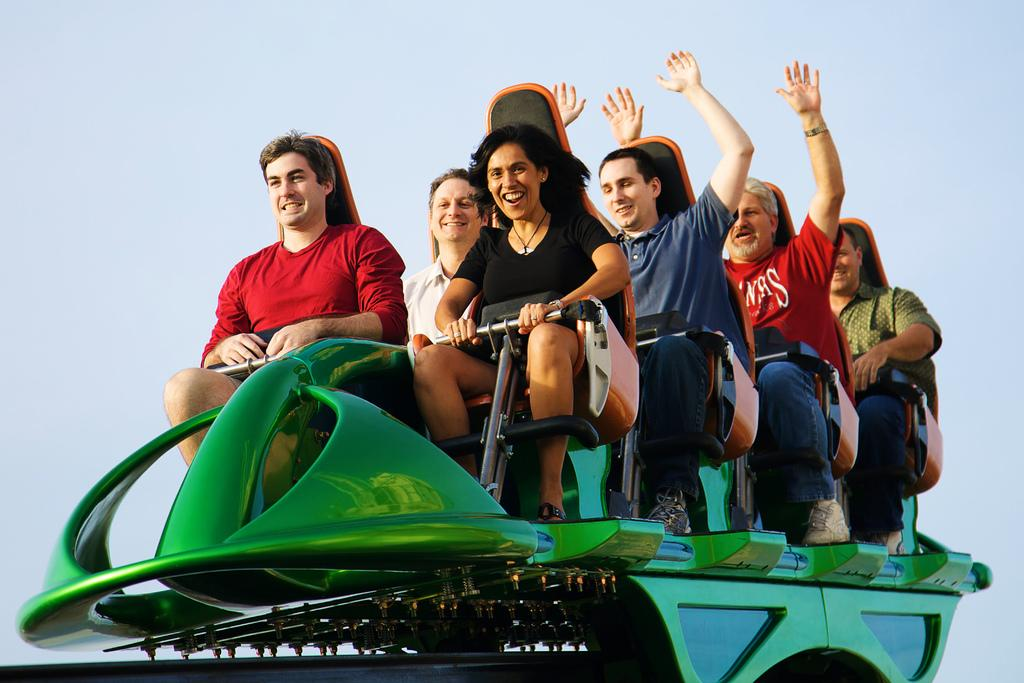What are the people in the image doing? The people are sitting in a ride. What can be seen in the background of the image? The sky is visible in the background of the image. What type of letters can be seen being written by the bat in the image? There is no bat or letters present in the image. 